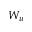<formula> <loc_0><loc_0><loc_500><loc_500>W _ { u }</formula> 